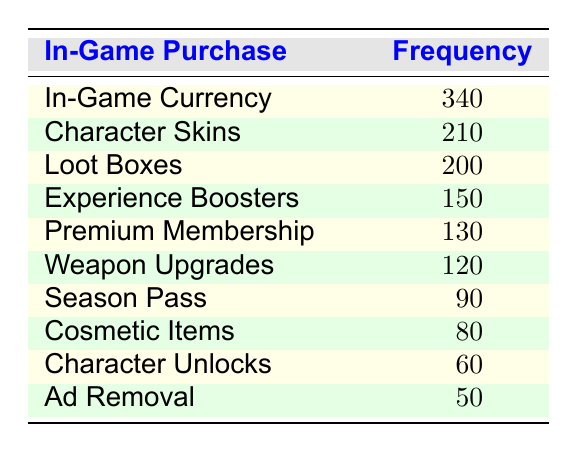What is the frequency of In-Game Currency purchases? The table explicitly lists In-Game Currency with a frequency of 340, so you can reference this row directly for the answer.
Answer: 340 Which in-game purchase has the lowest frequency? Looking at the table, the item with the lowest frequency is Ad Removal with a frequency of 50, as it is the last item listed and has the least value compared to the others.
Answer: Ad Removal What is the total frequency of Character Skins and Loot Boxes combined? To find the combined frequency, we add the frequencies of Character Skins (210) and Loot Boxes (200). This results in a total of 210 + 200 = 410.
Answer: 410 Is the frequency of Premium Membership greater than that of Season Pass? The frequency for Premium Membership is 130 and that for Season Pass is 90. Since 130 is greater than 90, the answer is yes.
Answer: Yes What is the average frequency of all in-game purchases? First, we sum the frequencies: 340 + 210 + 200 + 150 + 90 + 120 + 80 + 130 + 60 + 50 = 1,430. Since there are 10 items, we divide the total by 10: 1,430 / 10 = 143.
Answer: 143 Which in-game purchase contributes to more than 200 purchases? The only item that contributes more than 200 purchases, as indicated in the table, is In-Game Currency with a frequency of 340. So this is a yes/no question that gives a clear response.
Answer: In-Game Currency How many more purchases were made for Character Skins compared to Cosmetic Items? Character Skins have a frequency of 210 while Cosmetic Items have a frequency of 80, so the difference is 210 - 80 = 130.
Answer: 130 Are there more character-related purchases (Character Skins, Character Unlocks) than weapon-related purchases (Weapon Upgrades)? Character Skins (210) + Character Unlocks (60) = 270. Weapon Upgrades have a frequency of 120. Since 270 > 120, the answer is yes.
Answer: Yes What is the frequency difference between Loot Boxes and Experience Boosters? The frequency of Loot Boxes is 200 and the frequency of Experience Boosters is 150. Therefore, the difference is 200 - 150 = 50.
Answer: 50 